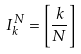<formula> <loc_0><loc_0><loc_500><loc_500>I _ { k } ^ { N } = \left [ \frac { k } { N } \right ]</formula> 